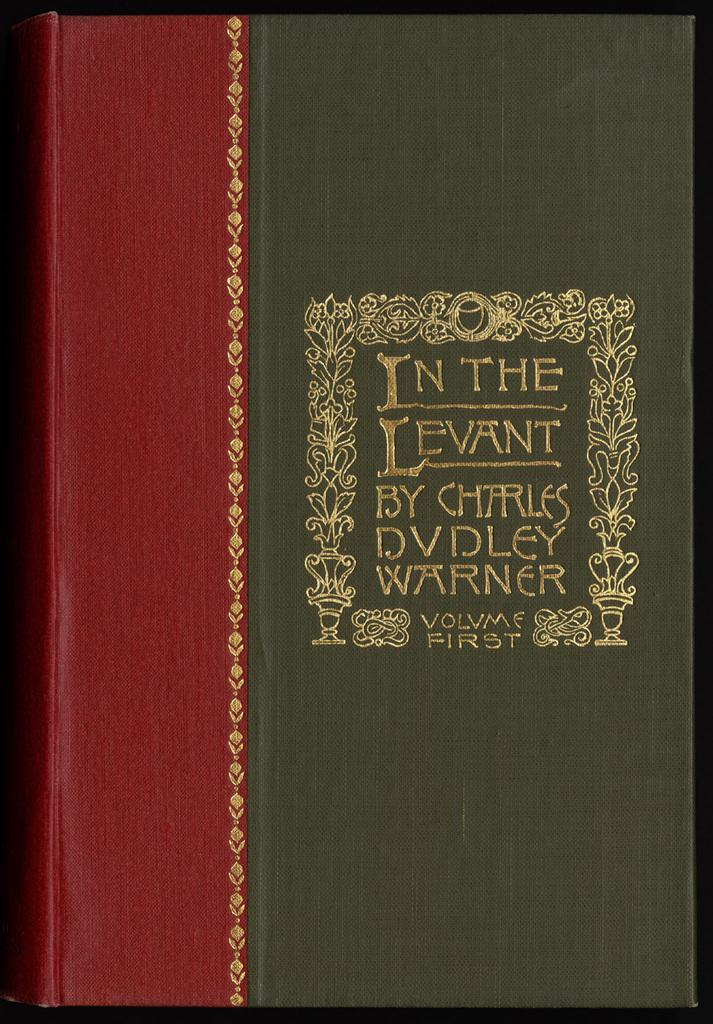<image>
Give a short and clear explanation of the subsequent image. A book by Charles Dudley Warner is displayed. 